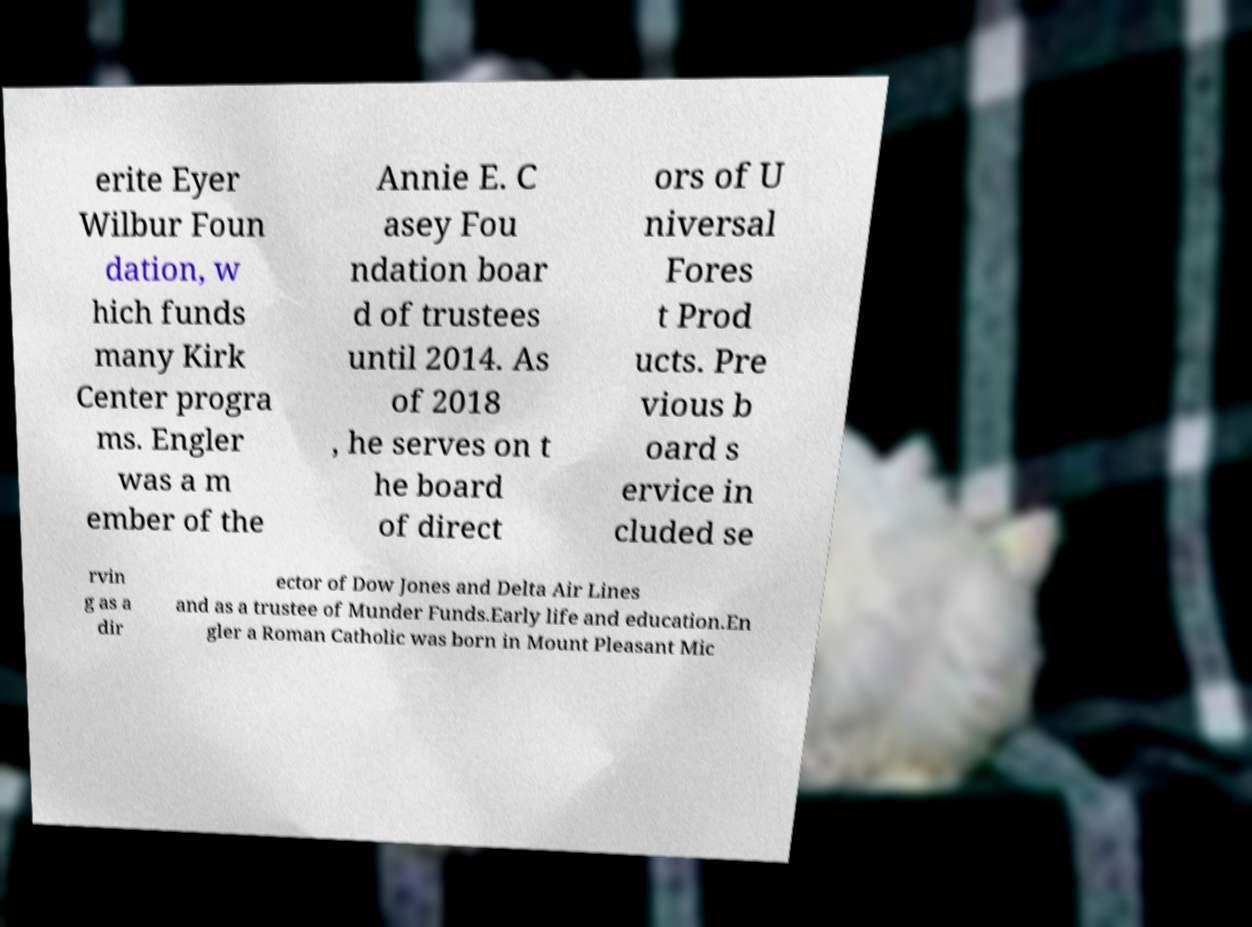What messages or text are displayed in this image? I need them in a readable, typed format. erite Eyer Wilbur Foun dation, w hich funds many Kirk Center progra ms. Engler was a m ember of the Annie E. C asey Fou ndation boar d of trustees until 2014. As of 2018 , he serves on t he board of direct ors of U niversal Fores t Prod ucts. Pre vious b oard s ervice in cluded se rvin g as a dir ector of Dow Jones and Delta Air Lines and as a trustee of Munder Funds.Early life and education.En gler a Roman Catholic was born in Mount Pleasant Mic 